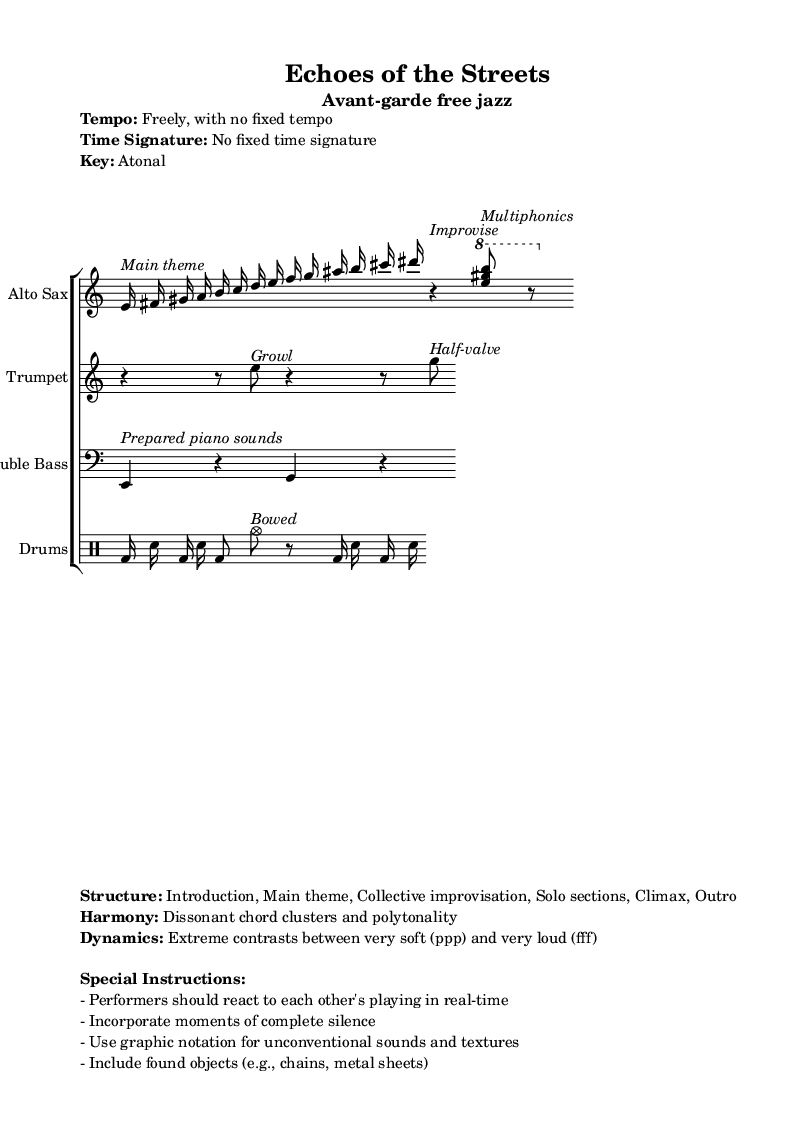What is the tempo of the piece? The tempo is indicated as "Freely, with no fixed tempo," which suggests that performers are encouraged to interpret the speed of the piece dynamically.
Answer: Freely, with no fixed tempo What is the time signature of the music? The time signature is indicated as "No fixed time signature," meaning that there isn't a traditional meter to follow, which is characteristic of avant-garde music.
Answer: No fixed time signature What is the key of this composition? The key is listed as "Atonal," which signifies that the music does not center around a specific tonal center or pitch, aligning with avant-garde musical aesthetics.
Answer: Atonal Which instruments are featured in the score? The score includes Alto Sax, Trumpet, Double Bass, and Drums, as indicated by the instrument names provided in their respective staves.
Answer: Alto Sax, Trumpet, Double Bass, Drums What type of improvisation is noted in the sheet? The sheet specifies "Collective improvisation" as part of the structure, indicating that the musicians participate in spontaneous creation together during performances.
Answer: Collective improvisation What unique playing techniques are incorporated? The instructions mention "Bowed" for the cymbal, "Half-valve" for trumpet, and "Prepared piano sounds" for double bass, all of which are unconventional techniques typical in avant-garde jazz.
Answer: Bowed, Half-valve, Prepared piano sounds What contrasts in dynamics are suggested? The dynamics are described as having "Extreme contrasts between very soft (ppp) and very loud (fff)," indicating a wide range of volume levels that performers should explore.
Answer: Extreme contrasts between very soft (ppp) and very loud (fff) 